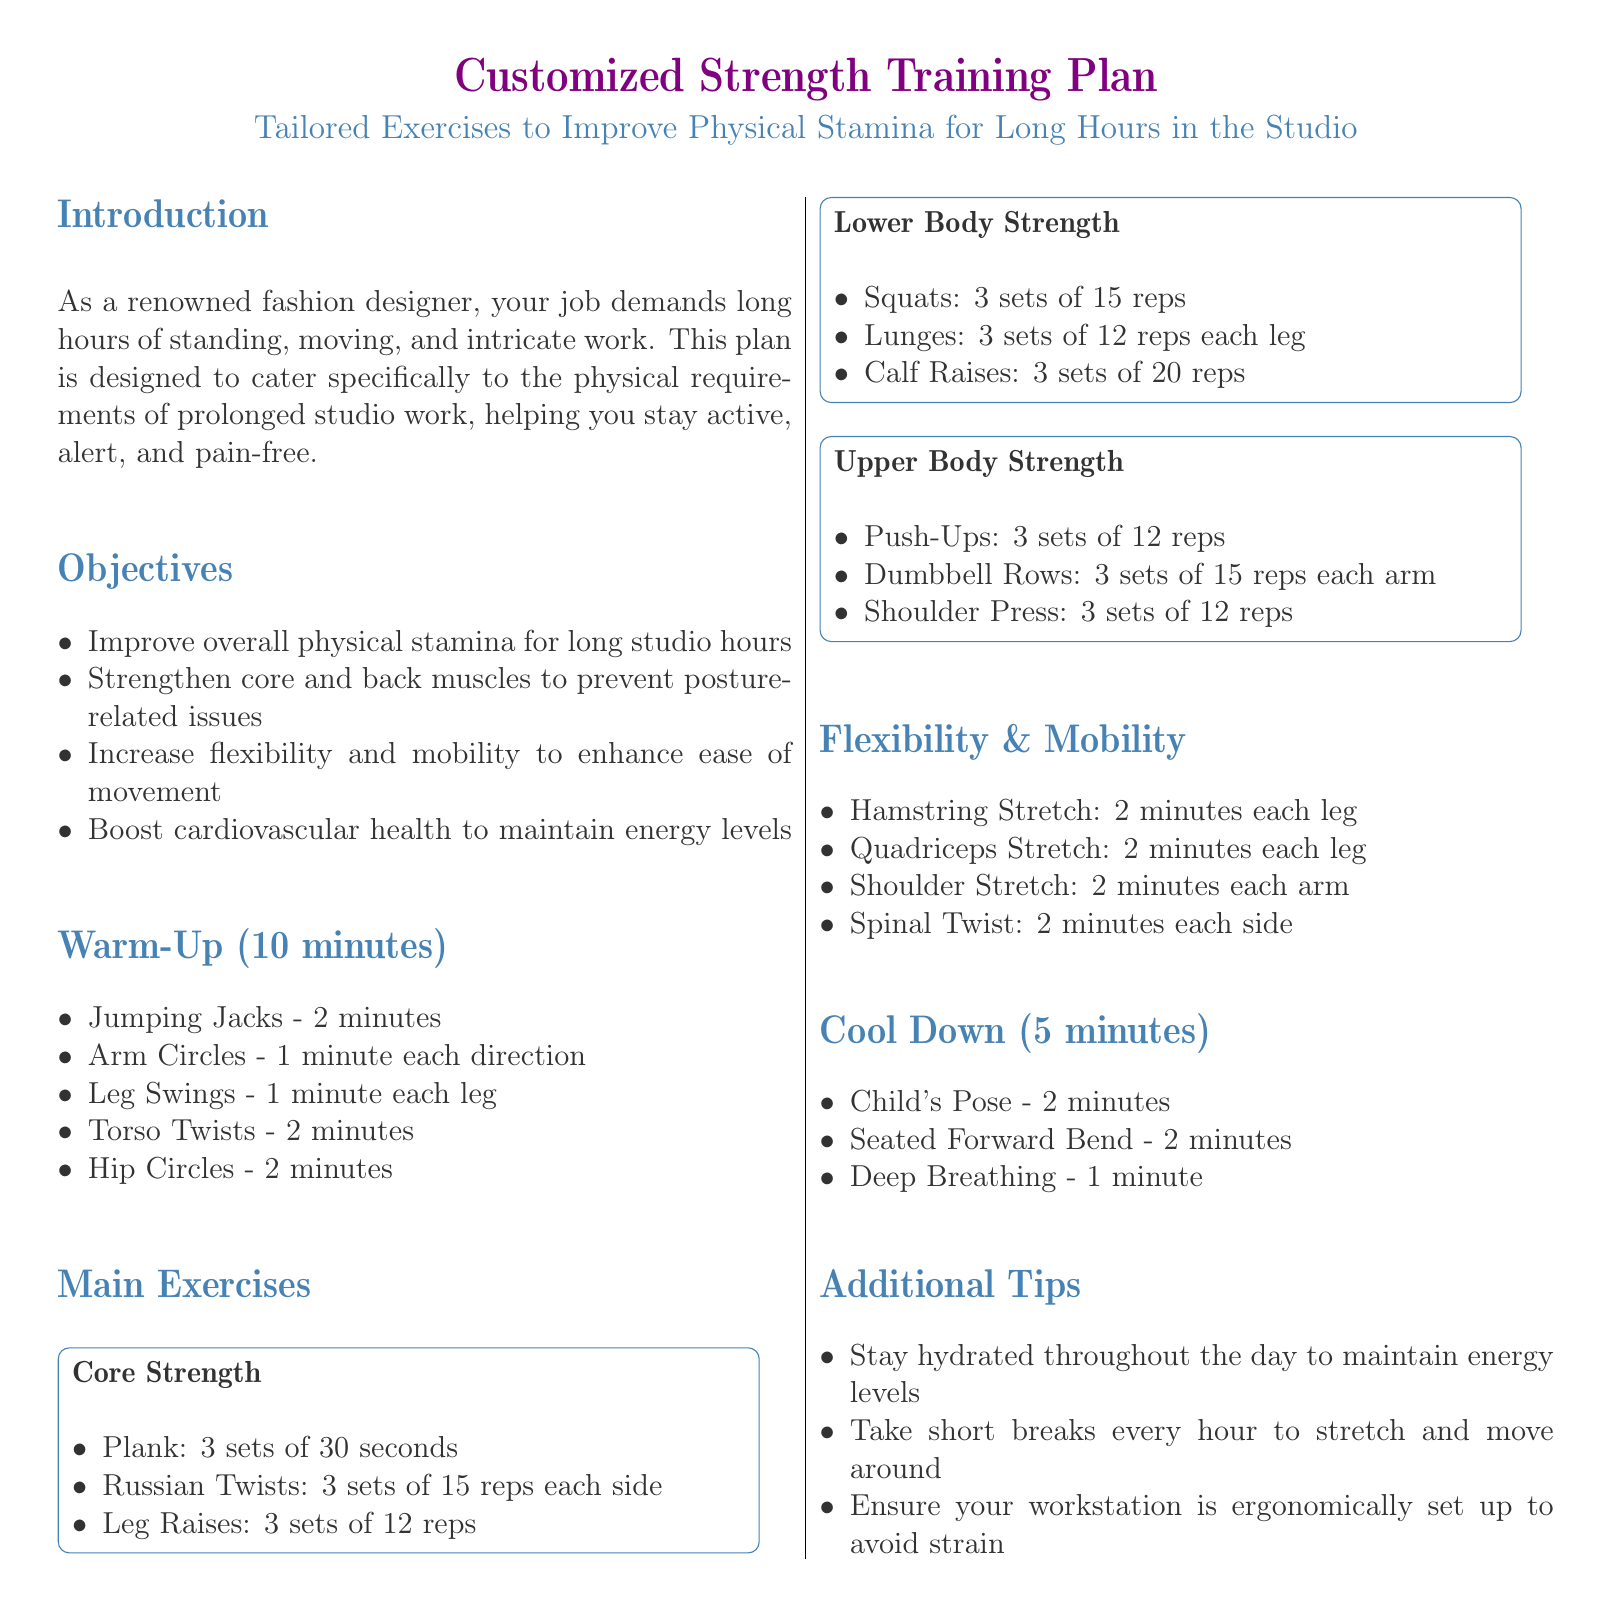what is the duration of the warm-up section? The duration of the warm-up section is specified in the document as 10 minutes.
Answer: 10 minutes how many sets of Plank are recommended? The document states that 3 sets of Plank are recommended for the Core Strength exercise.
Answer: 3 sets what exercise is suggested for flexibility and mobility? The document lists several exercises for flexibility and mobility, one of which is the Hamstring Stretch.
Answer: Hamstring Stretch what is one objective of the workout plan? The document outlines several objectives, one being to improve overall physical stamina for long studio hours.
Answer: Improve overall physical stamina how many repetitions are prescribed for Lunges? The recommended number of repetitions for Lunges is stated as 12 reps each leg.
Answer: 12 reps each leg which exercise is included in the cool down? One of the exercises included in the cool down is the Child's Pose.
Answer: Child's Pose what is the recommended duration for the Child's Pose? The document specifies that the recommended duration for the Child's Pose during cool down is 2 minutes.
Answer: 2 minutes how many exercises are listed under Lower Body Strength? The document lists three exercises under Lower Body Strength: Squats, Lunges, and Calf Raises.
Answer: 3 exercises 